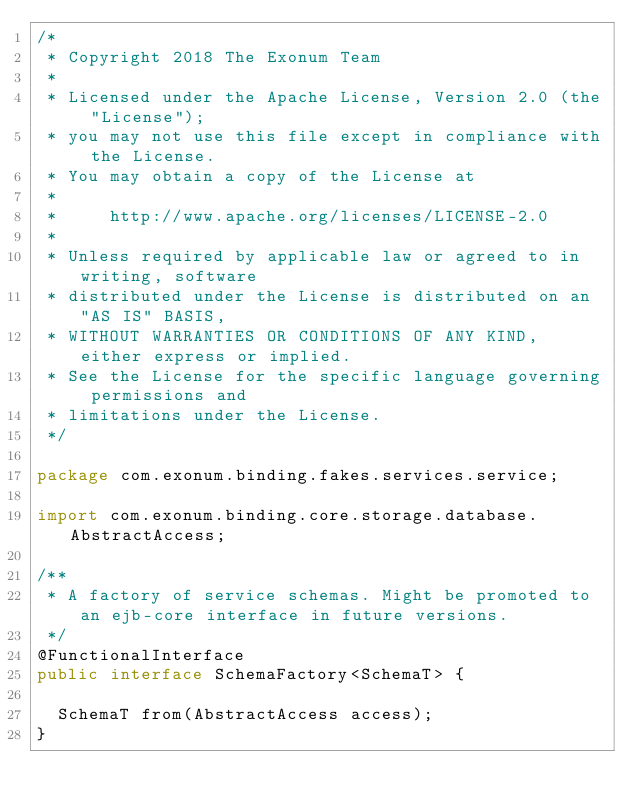<code> <loc_0><loc_0><loc_500><loc_500><_Java_>/*
 * Copyright 2018 The Exonum Team
 *
 * Licensed under the Apache License, Version 2.0 (the "License");
 * you may not use this file except in compliance with the License.
 * You may obtain a copy of the License at
 *
 *     http://www.apache.org/licenses/LICENSE-2.0
 *
 * Unless required by applicable law or agreed to in writing, software
 * distributed under the License is distributed on an "AS IS" BASIS,
 * WITHOUT WARRANTIES OR CONDITIONS OF ANY KIND, either express or implied.
 * See the License for the specific language governing permissions and
 * limitations under the License.
 */

package com.exonum.binding.fakes.services.service;

import com.exonum.binding.core.storage.database.AbstractAccess;

/**
 * A factory of service schemas. Might be promoted to an ejb-core interface in future versions.
 */
@FunctionalInterface
public interface SchemaFactory<SchemaT> {

  SchemaT from(AbstractAccess access);
}
</code> 